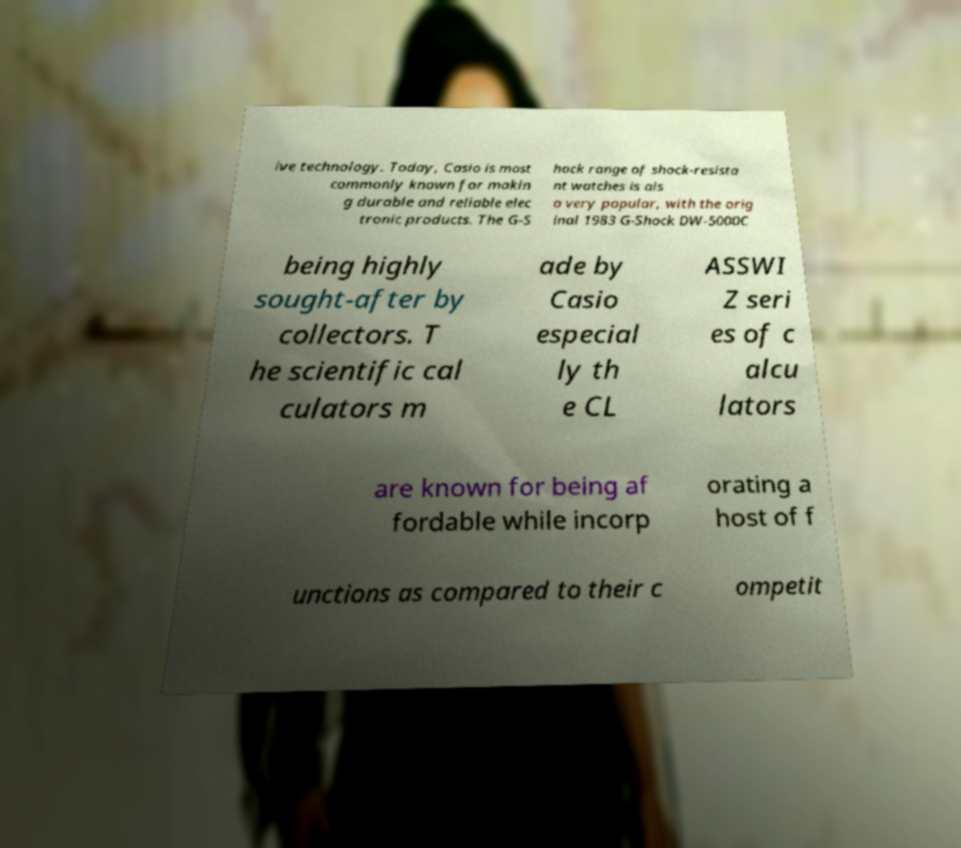Can you accurately transcribe the text from the provided image for me? ive technology. Today, Casio is most commonly known for makin g durable and reliable elec tronic products. The G-S hock range of shock-resista nt watches is als o very popular, with the orig inal 1983 G-Shock DW-5000C being highly sought-after by collectors. T he scientific cal culators m ade by Casio especial ly th e CL ASSWI Z seri es of c alcu lators are known for being af fordable while incorp orating a host of f unctions as compared to their c ompetit 